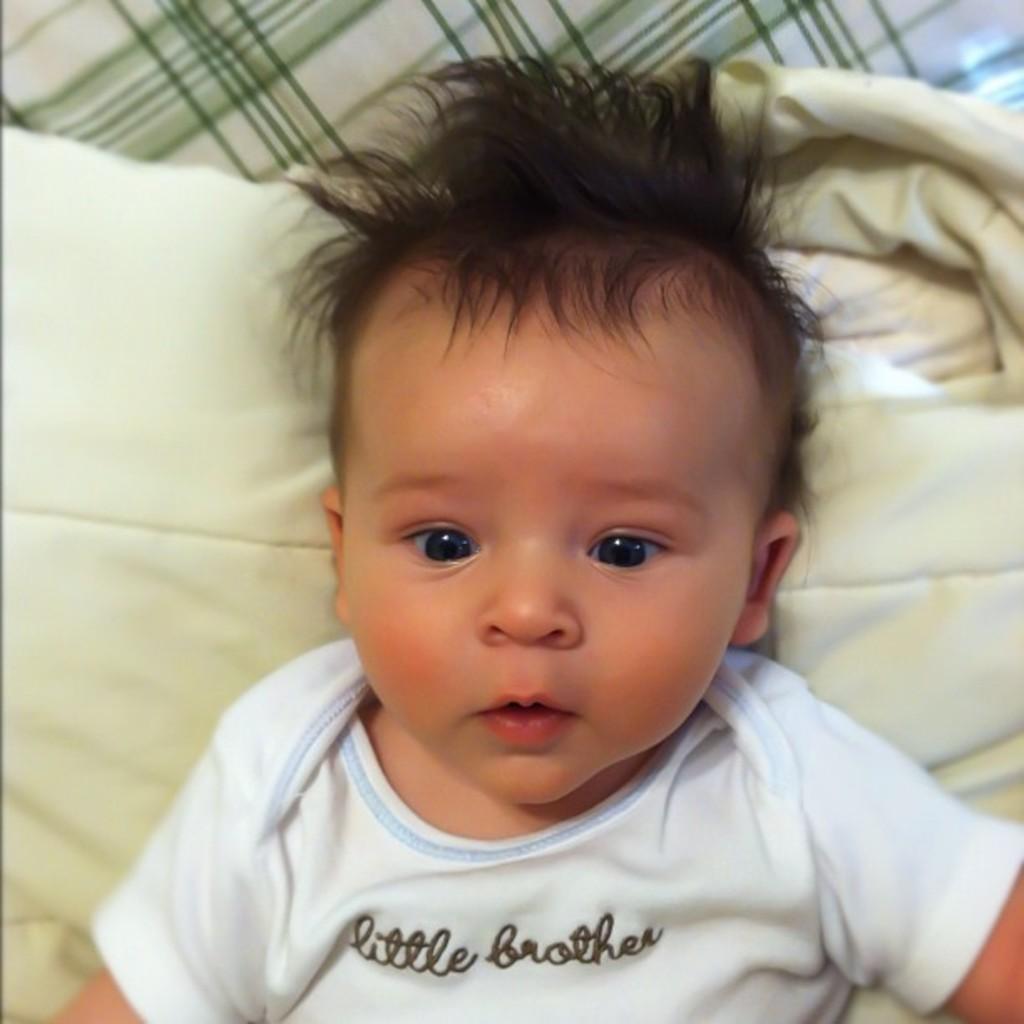Please provide a concise description of this image. In the image there is a baby in white t-shirt laying on bed. 